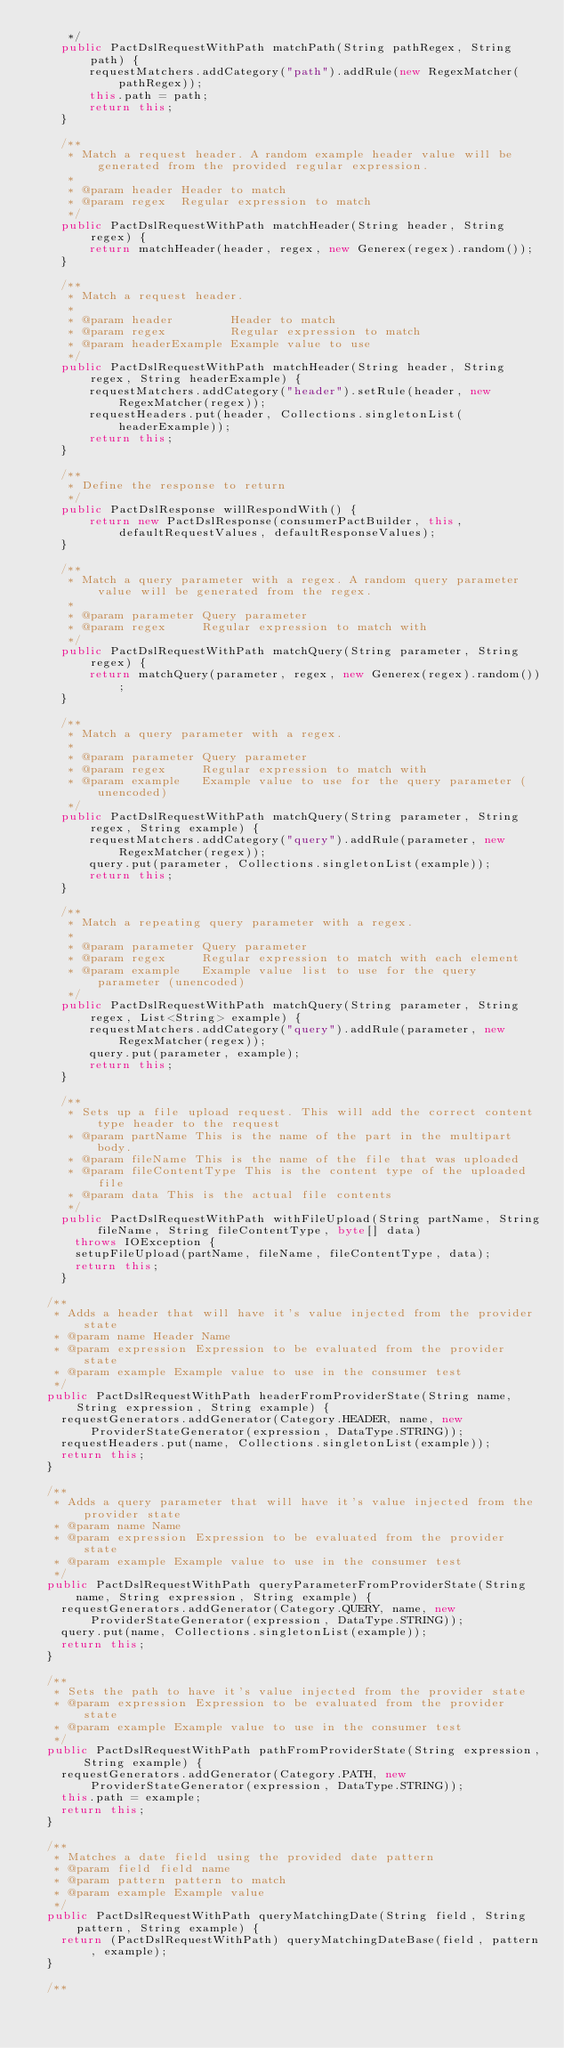<code> <loc_0><loc_0><loc_500><loc_500><_Java_>     */
    public PactDslRequestWithPath matchPath(String pathRegex, String path) {
        requestMatchers.addCategory("path").addRule(new RegexMatcher(pathRegex));
        this.path = path;
        return this;
    }

    /**
     * Match a request header. A random example header value will be generated from the provided regular expression.
     *
     * @param header Header to match
     * @param regex  Regular expression to match
     */
    public PactDslRequestWithPath matchHeader(String header, String regex) {
        return matchHeader(header, regex, new Generex(regex).random());
    }

    /**
     * Match a request header.
     *
     * @param header        Header to match
     * @param regex         Regular expression to match
     * @param headerExample Example value to use
     */
    public PactDslRequestWithPath matchHeader(String header, String regex, String headerExample) {
        requestMatchers.addCategory("header").setRule(header, new RegexMatcher(regex));
        requestHeaders.put(header, Collections.singletonList(headerExample));
        return this;
    }

    /**
     * Define the response to return
     */
    public PactDslResponse willRespondWith() {
        return new PactDslResponse(consumerPactBuilder, this, defaultRequestValues, defaultResponseValues);
    }

    /**
     * Match a query parameter with a regex. A random query parameter value will be generated from the regex.
     *
     * @param parameter Query parameter
     * @param regex     Regular expression to match with
     */
    public PactDslRequestWithPath matchQuery(String parameter, String regex) {
        return matchQuery(parameter, regex, new Generex(regex).random());
    }

    /**
     * Match a query parameter with a regex.
     *
     * @param parameter Query parameter
     * @param regex     Regular expression to match with
     * @param example   Example value to use for the query parameter (unencoded)
     */
    public PactDslRequestWithPath matchQuery(String parameter, String regex, String example) {
        requestMatchers.addCategory("query").addRule(parameter, new RegexMatcher(regex));
        query.put(parameter, Collections.singletonList(example));
        return this;
    }

    /**
     * Match a repeating query parameter with a regex.
     *
     * @param parameter Query parameter
     * @param regex     Regular expression to match with each element
     * @param example   Example value list to use for the query parameter (unencoded)
     */
    public PactDslRequestWithPath matchQuery(String parameter, String regex, List<String> example) {
        requestMatchers.addCategory("query").addRule(parameter, new RegexMatcher(regex));
        query.put(parameter, example);
        return this;
    }

    /**
     * Sets up a file upload request. This will add the correct content type header to the request
     * @param partName This is the name of the part in the multipart body.
     * @param fileName This is the name of the file that was uploaded
     * @param fileContentType This is the content type of the uploaded file
     * @param data This is the actual file contents
     */
    public PactDslRequestWithPath withFileUpload(String partName, String fileName, String fileContentType, byte[] data)
      throws IOException {
      setupFileUpload(partName, fileName, fileContentType, data);
      return this;
    }

  /**
   * Adds a header that will have it's value injected from the provider state
   * @param name Header Name
   * @param expression Expression to be evaluated from the provider state
   * @param example Example value to use in the consumer test
   */
  public PactDslRequestWithPath headerFromProviderState(String name, String expression, String example) {
    requestGenerators.addGenerator(Category.HEADER, name, new ProviderStateGenerator(expression, DataType.STRING));
    requestHeaders.put(name, Collections.singletonList(example));
    return this;
  }

  /**
   * Adds a query parameter that will have it's value injected from the provider state
   * @param name Name
   * @param expression Expression to be evaluated from the provider state
   * @param example Example value to use in the consumer test
   */
  public PactDslRequestWithPath queryParameterFromProviderState(String name, String expression, String example) {
    requestGenerators.addGenerator(Category.QUERY, name, new ProviderStateGenerator(expression, DataType.STRING));
    query.put(name, Collections.singletonList(example));
    return this;
  }

  /**
   * Sets the path to have it's value injected from the provider state
   * @param expression Expression to be evaluated from the provider state
   * @param example Example value to use in the consumer test
   */
  public PactDslRequestWithPath pathFromProviderState(String expression, String example) {
    requestGenerators.addGenerator(Category.PATH, new ProviderStateGenerator(expression, DataType.STRING));
    this.path = example;
    return this;
  }

  /**
   * Matches a date field using the provided date pattern
   * @param field field name
   * @param pattern pattern to match
   * @param example Example value
   */
  public PactDslRequestWithPath queryMatchingDate(String field, String pattern, String example) {
    return (PactDslRequestWithPath) queryMatchingDateBase(field, pattern, example);
  }

  /**</code> 